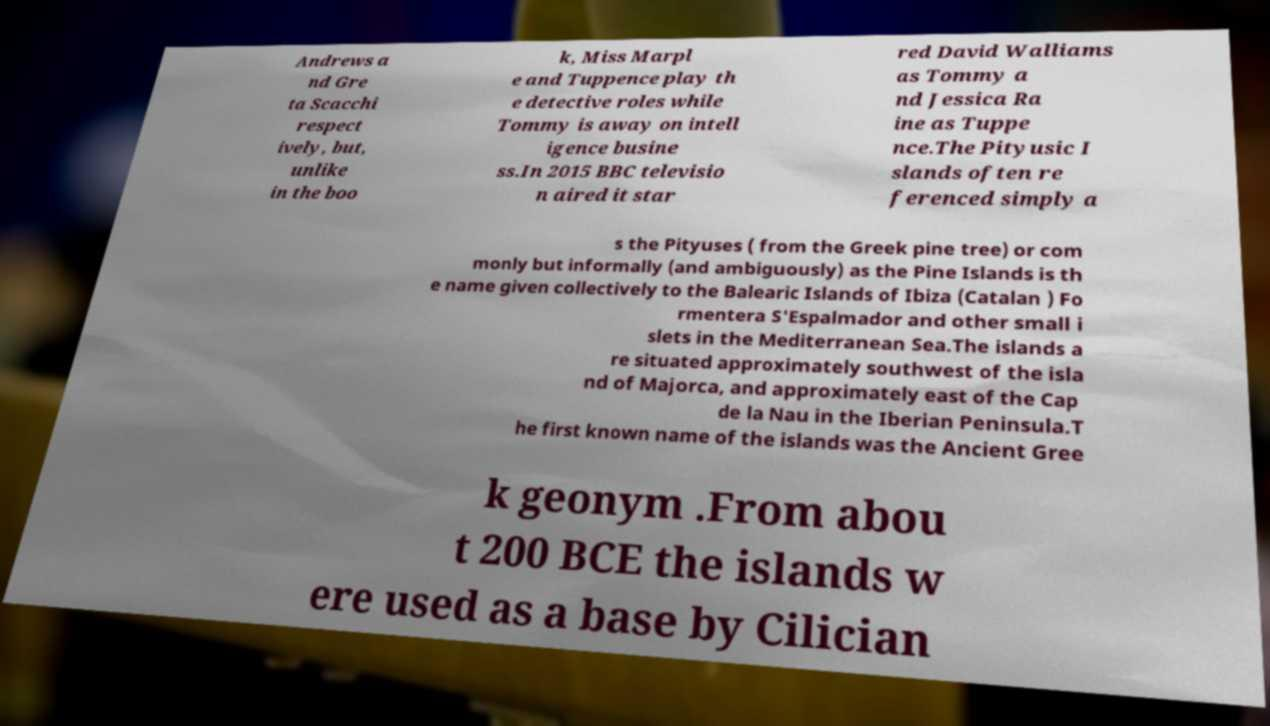For documentation purposes, I need the text within this image transcribed. Could you provide that? Andrews a nd Gre ta Scacchi respect ively, but, unlike in the boo k, Miss Marpl e and Tuppence play th e detective roles while Tommy is away on intell igence busine ss.In 2015 BBC televisio n aired it star red David Walliams as Tommy a nd Jessica Ra ine as Tuppe nce.The Pityusic I slands often re ferenced simply a s the Pityuses ( from the Greek pine tree) or com monly but informally (and ambiguously) as the Pine Islands is th e name given collectively to the Balearic Islands of Ibiza (Catalan ) Fo rmentera S'Espalmador and other small i slets in the Mediterranean Sea.The islands a re situated approximately southwest of the isla nd of Majorca, and approximately east of the Cap de la Nau in the Iberian Peninsula.T he first known name of the islands was the Ancient Gree k geonym .From abou t 200 BCE the islands w ere used as a base by Cilician 